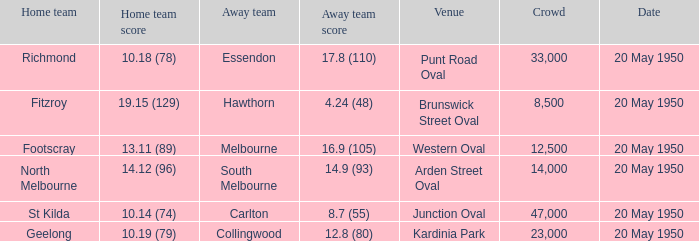What was the venue when the away team scored 14.9 (93)? Arden Street Oval. 